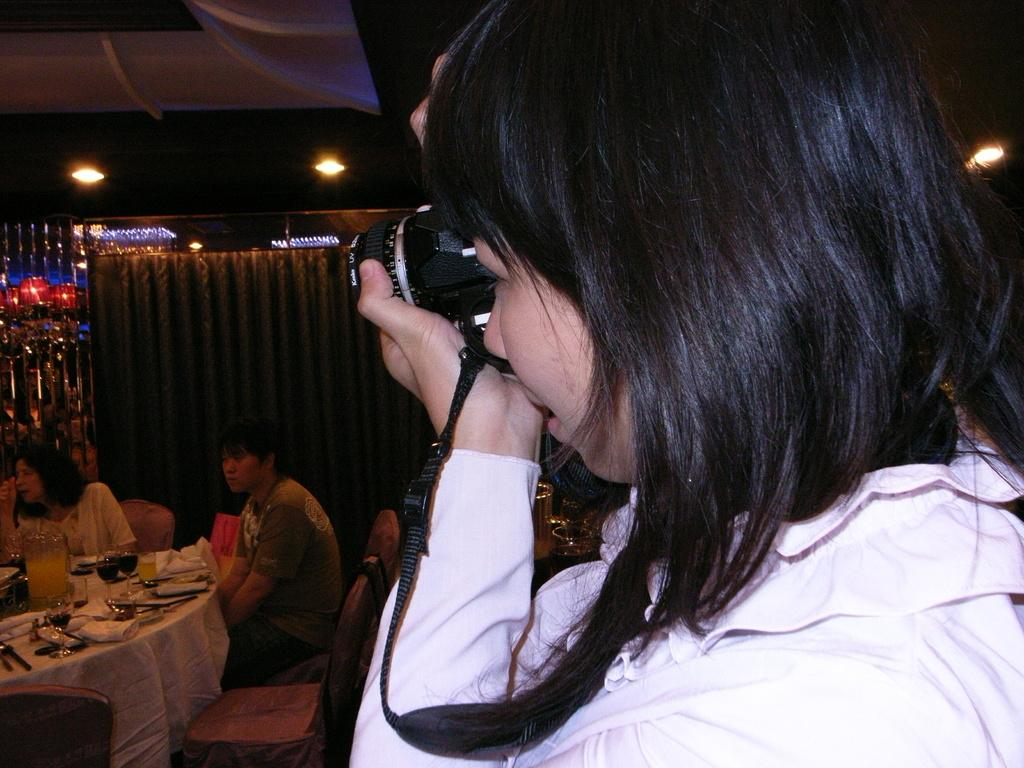Who is holding the camera in the image? There is a person holding the camera in the image. How many people are sitting to the left of the image? There are two people sitting to the left of the image. What are the two people sitting in front of? The two people are sitting in front of a table. What can be seen on the table in the image? There is a glass, spoons, and tissues on the table. What type of brush is being used by the person sitting on the right side of the image? There is no person sitting on the right side of the image, and no brush is visible in the image. How many cakes are being served on the table in the image? There are no cakes present on the table in the image. 